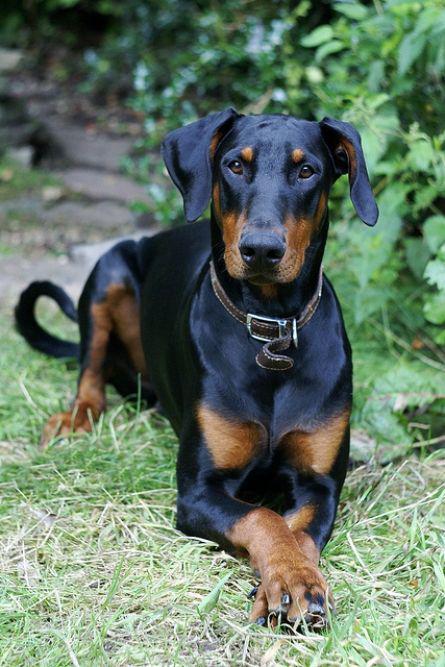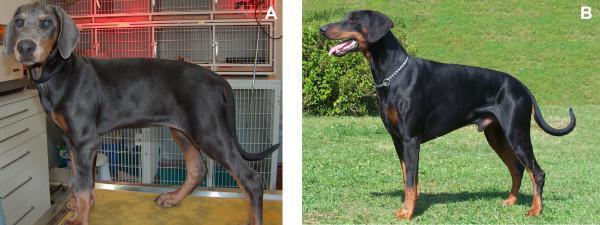The first image is the image on the left, the second image is the image on the right. For the images displayed, is the sentence "The left image shows a doberman with erect ears and docked tail standing with his chest facing forward in front of at least one tall tree." factually correct? Answer yes or no. No. 